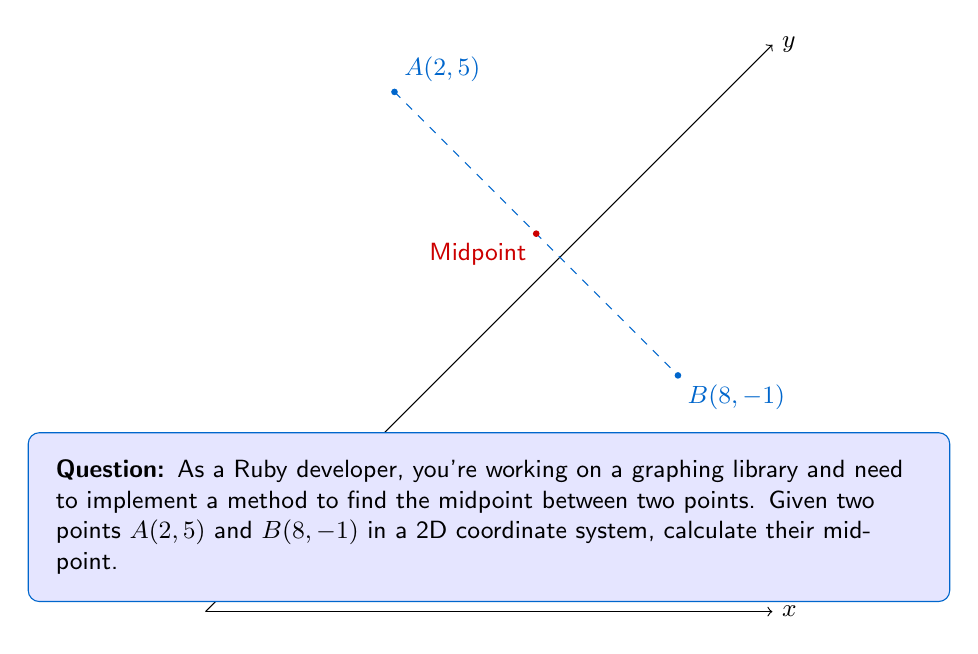Can you answer this question? To find the midpoint between two points in a 2D coordinate system, we use the midpoint formula:

$$ M_x = \frac{x_1 + x_2}{2}, \quad M_y = \frac{y_1 + y_2}{2} $$

Where $(M_x, M_y)$ is the midpoint, $(x_1, y_1)$ is the first point, and $(x_2, y_2)$ is the second point.

Given:
- Point A: $(2, 5)$
- Point B: $(8, -1)$

Step 1: Calculate $M_x$
$$ M_x = \frac{x_1 + x_2}{2} = \frac{2 + 8}{2} = \frac{10}{2} = 5 $$

Step 2: Calculate $M_y$
$$ M_y = \frac{y_1 + y_2}{2} = \frac{5 + (-1)}{2} = \frac{4}{2} = 2 $$

Therefore, the midpoint is $(5, 2)$.
Answer: $(5, 2)$ 